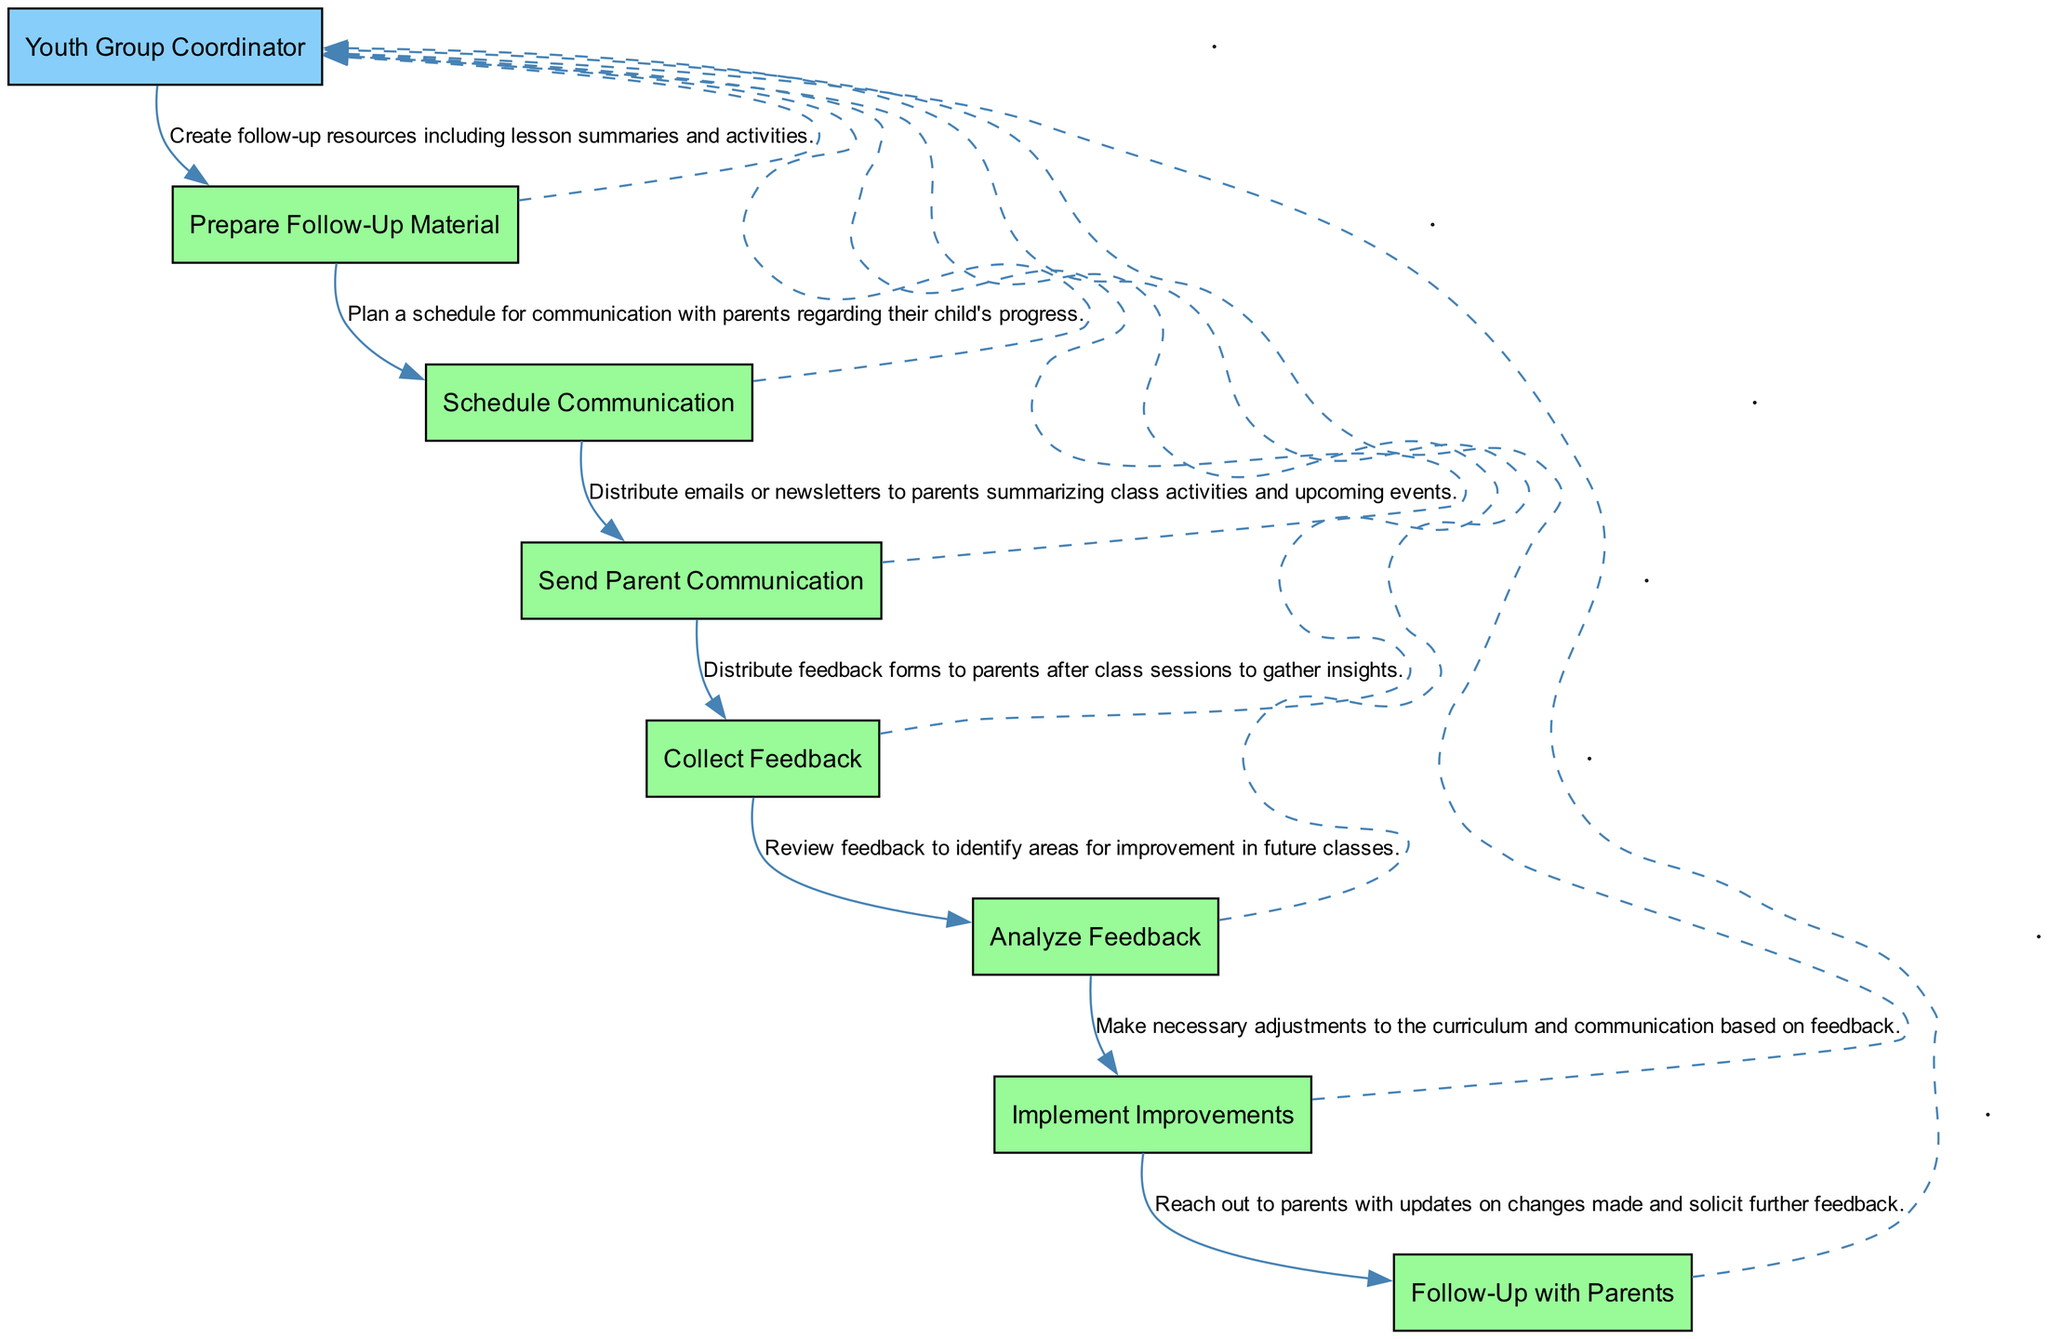What is the first step in the follow-up plan? The first step is "Prepare Follow-Up Material" as indicated by the initial box in the sequence diagram.
Answer: Prepare Follow-Up Material How many steps are involved in the follow-up plan? The diagram shows a total of 7 distinct steps that outline the follow-up plan.
Answer: 7 Which actor is responsible for all steps in the diagram? The "Youth Group Coordinator" is the only actor listed carrying out all the steps in the sequence.
Answer: Youth Group Coordinator What is the last step shown in the sequence? The last step, as indicated in the final box of the sequence diagram, is "Follow-Up with Parents."
Answer: Follow-Up with Parents What action follows "Collect Feedback"? "Analyze Feedback" follows "Collect Feedback" as seen in the flow of the diagram, where each step leads to the next.
Answer: Analyze Feedback Which step involves distributing emails or newsletters to parents? The step that involves distributing emails or newsletters is "Send Parent Communication," which explicitly mentions this action.
Answer: Send Parent Communication How many interactions connect the "Youth Group Coordinator" to the steps? The "Youth Group Coordinator" is connected to each of the 7 steps, resulting in 7 interactions visible in the diagram.
Answer: 7 What is the purpose of the "Implement Improvements" step? The purpose of the "Implement Improvements" step is to make adjustments based on the feedback collected from parents.
Answer: Make necessary adjustments What connects the steps in the sequence? The steps in the sequence are connected by directed edges that show the order of operations and the actions required at each point.
Answer: Directed edges 